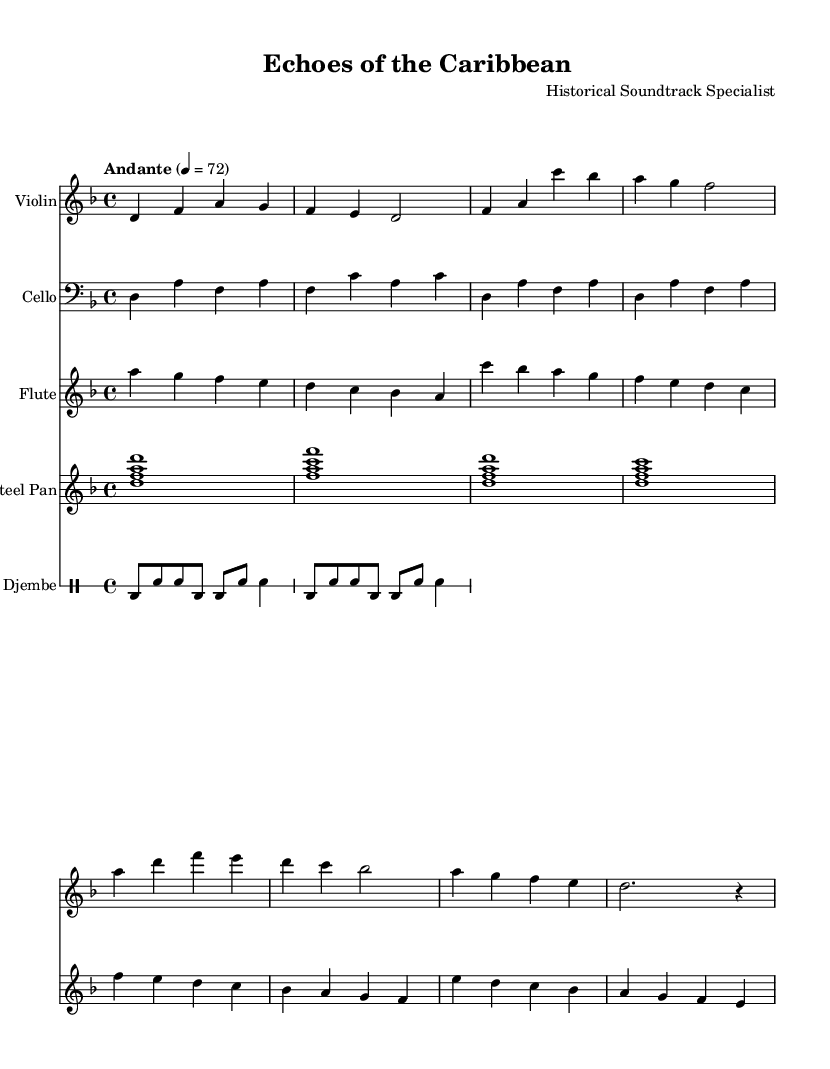What is the key signature of this music? The key signature indicates D minor, which has one flat (B-flat). It can be identified by looking at the key signature section at the beginning of the score.
Answer: D minor What is the time signature of this music? The time signature is 4/4, which is represented right after the key signature. It indicates that there are 4 beats in each measure and each beat is a quarter note.
Answer: 4/4 What is the indicated tempo for the piece? The tempo marking is "Andante" and is shown right above the staff, along with the metronome marking of 72 beats per minute. This indicates a moderate walking pace.
Answer: Andante, 72 Which instruments are included in the score? The score includes Violin, Cello, Flute, Steel Pan, and Djembe. Each instrument is labeled at the start of its staff.
Answer: Violin, Cello, Flute, Steel Pan, Djembe How many measures are in the Violin part? The Violin part consists of 8 measures, as each staff is divided into segments marked by vertical lines, known as bar lines. Upon counting, there are 8 visible measures in total.
Answer: 8 What rhythmic pattern does the Djembe play? The Djembe pattern consists of a specified sequence of bass and snare hits, which is illustrated in the drum notation part of the score, showing a repeated 8-note rhythm followed by a 4-note rhythmic closing.
Answer: Bass and snare rhythm pattern Which instrument plays the melody primarily? The Flute part carries the main melody, as it typically plays higher pitches and more intricate melodic lines compared to the accompanying instruments. It can be identified through its distinct melodic phrases compared to the harmonizing instruments.
Answer: Flute 